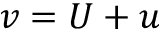<formula> <loc_0><loc_0><loc_500><loc_500>v = U + u</formula> 